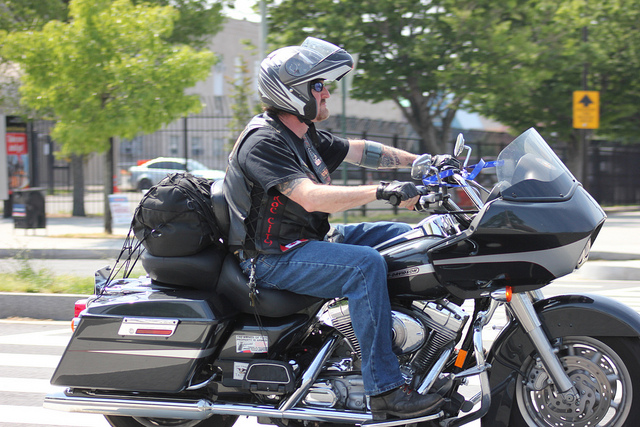How many people are on the bike? There is one person riding the motorcycle, clad in protective bike gear with a helmet, and looks focused on the road. 